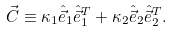<formula> <loc_0><loc_0><loc_500><loc_500>\vec { C } \equiv \kappa _ { 1 } \hat { \vec { e } } _ { 1 } \hat { \vec { e } } _ { 1 } ^ { T } + \kappa _ { 2 } \hat { \vec { e } } _ { 2 } \hat { \vec { e } } _ { 2 } ^ { T } .</formula> 